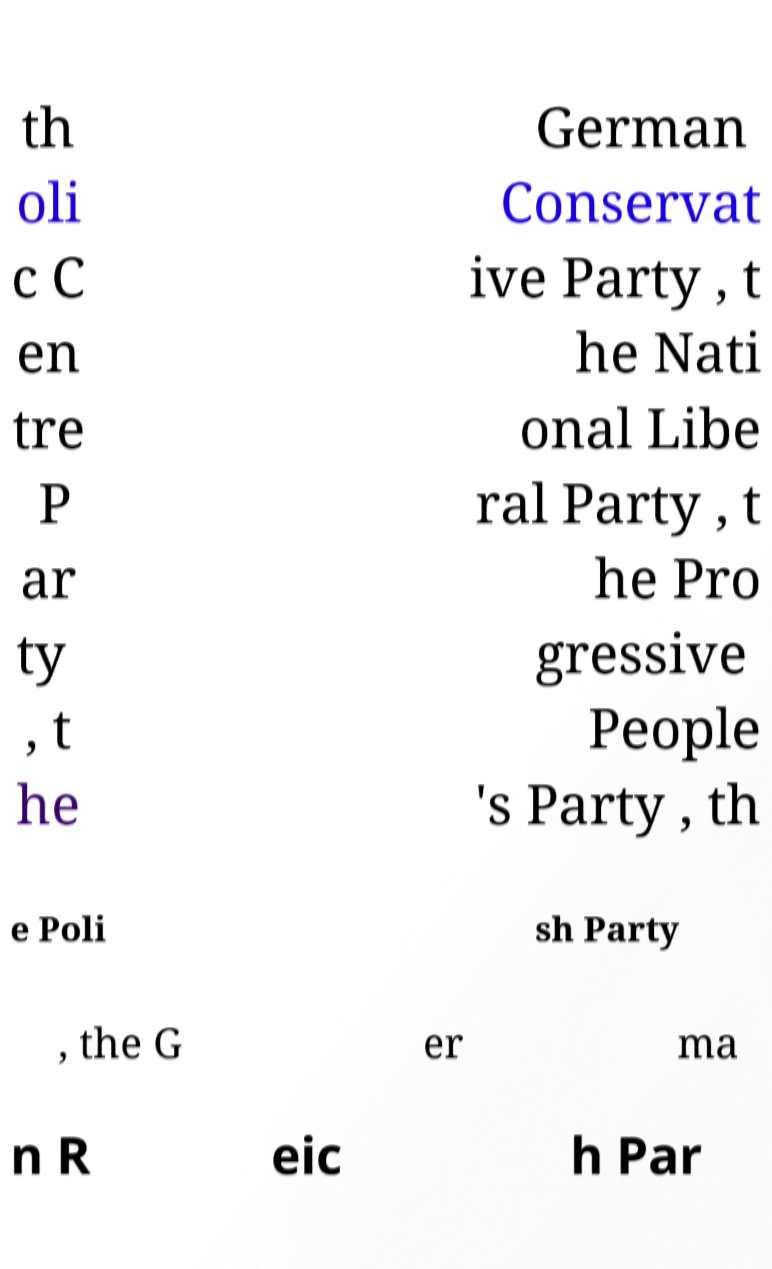Can you accurately transcribe the text from the provided image for me? th oli c C en tre P ar ty , t he German Conservat ive Party , t he Nati onal Libe ral Party , t he Pro gressive People 's Party , th e Poli sh Party , the G er ma n R eic h Par 